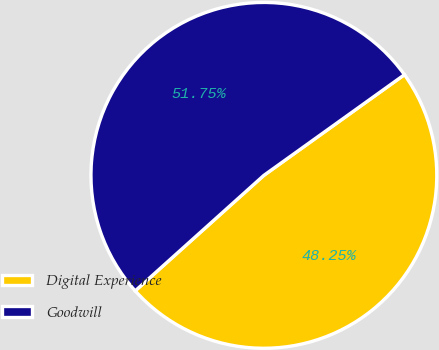Convert chart to OTSL. <chart><loc_0><loc_0><loc_500><loc_500><pie_chart><fcel>Digital Experience<fcel>Goodwill<nl><fcel>48.25%<fcel>51.75%<nl></chart> 